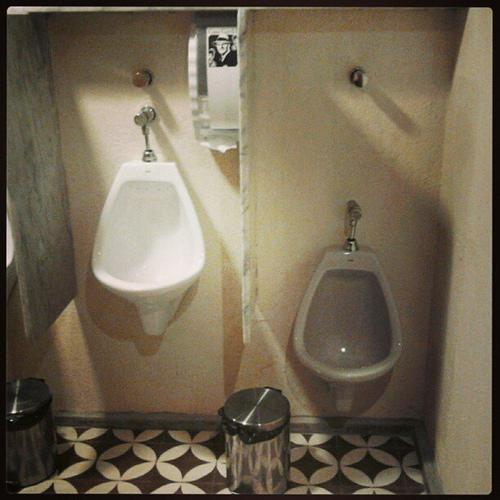Question: when was the photo taken?
Choices:
A. Nighttime.
B. Christmas.
C. Day time.
D. Thanksgiving.
Answer with the letter. Answer: C Question: what color is the trash can?
Choices:
A. Silver.
B. Green.
C. White.
D. Grey.
Answer with the letter. Answer: A Question: what color is the urinal on the left?
Choices:
A. Black.
B. Silver.
C. Grey.
D. White.
Answer with the letter. Answer: D Question: where was the photo taken?
Choices:
A. The bathroom.
B. The kitchen.
C. A bedroom.
D. Garage.
Answer with the letter. Answer: A Question: what color is the floor?
Choices:
A. White.
B. Black.
C. Grey.
D. Brown.
Answer with the letter. Answer: B 